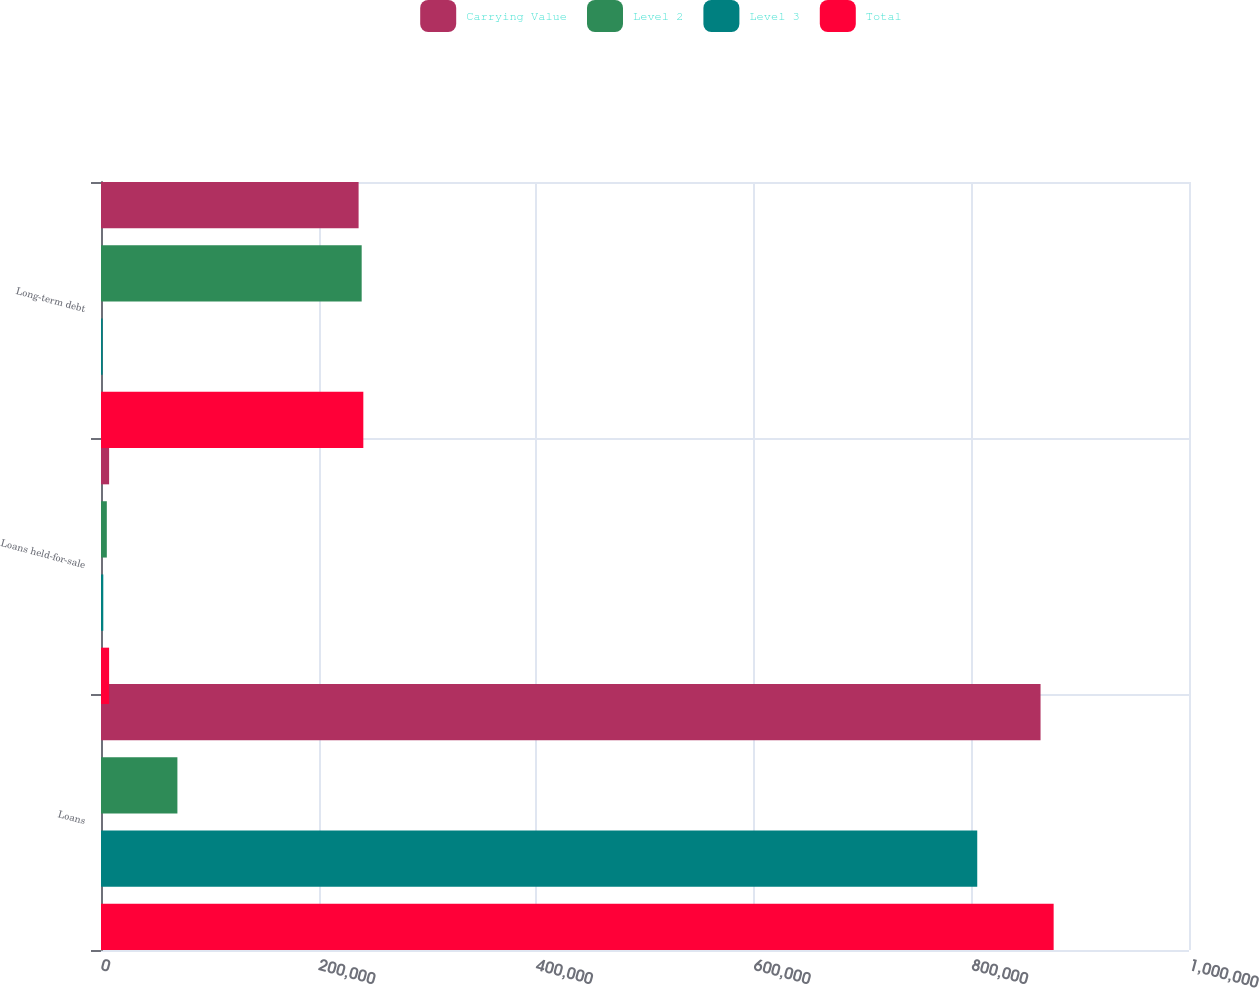Convert chart. <chart><loc_0><loc_0><loc_500><loc_500><stacked_bar_chart><ecel><fcel>Loans<fcel>Loans held-for-sale<fcel>Long-term debt<nl><fcel>Carrying Value<fcel>863561<fcel>7453<fcel>236764<nl><fcel>Level 2<fcel>70223<fcel>5347<fcel>239596<nl><fcel>Level 3<fcel>805371<fcel>2106<fcel>1513<nl><fcel>Total<fcel>875594<fcel>7453<fcel>241109<nl></chart> 